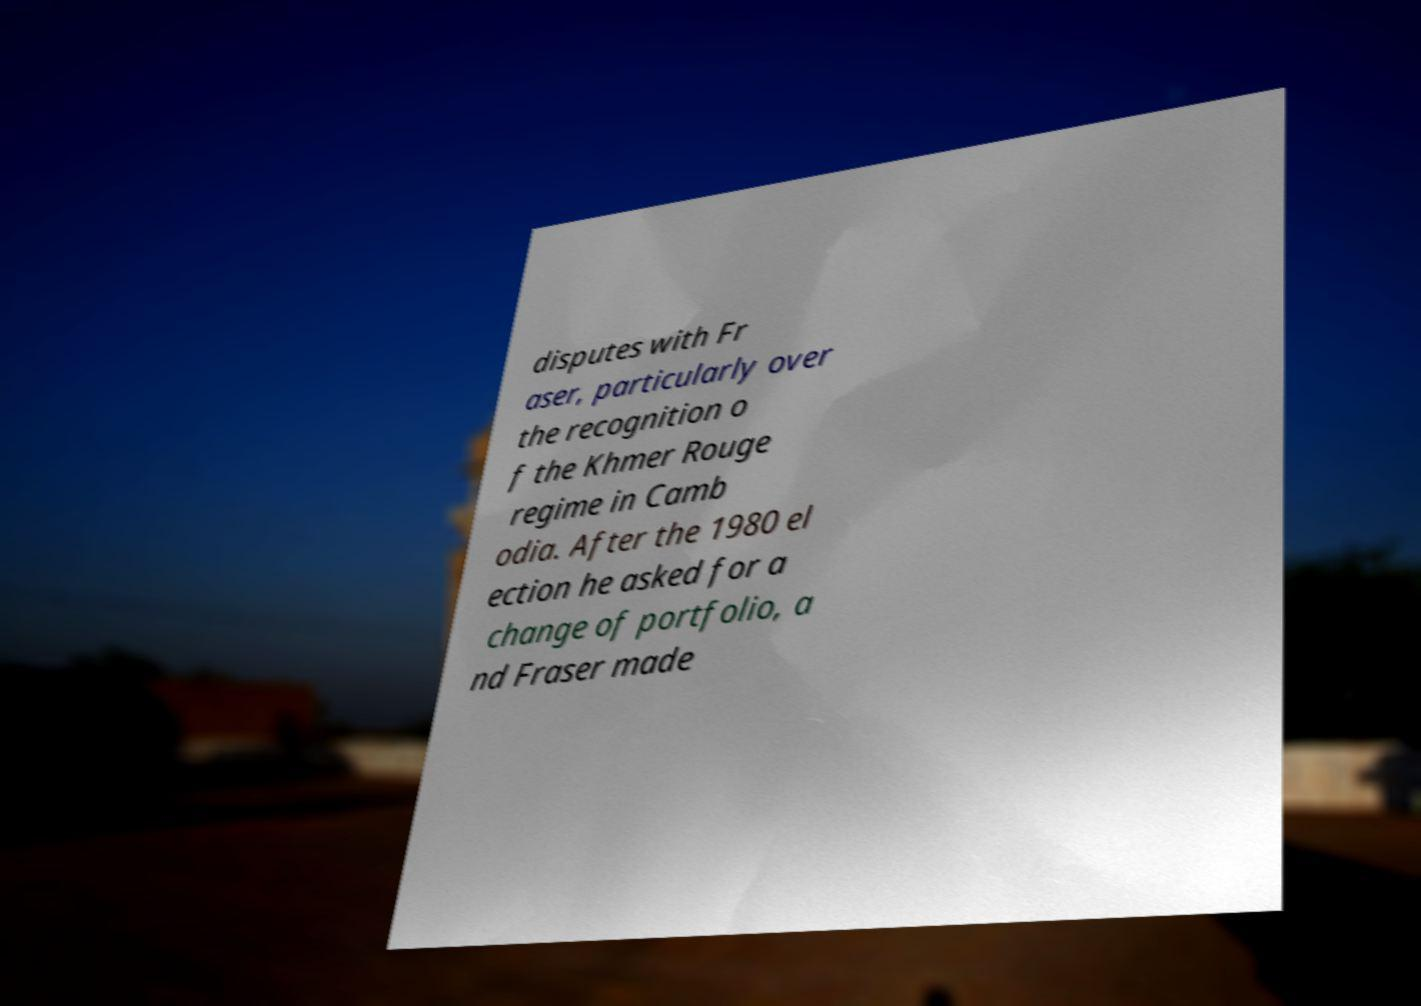For documentation purposes, I need the text within this image transcribed. Could you provide that? disputes with Fr aser, particularly over the recognition o f the Khmer Rouge regime in Camb odia. After the 1980 el ection he asked for a change of portfolio, a nd Fraser made 